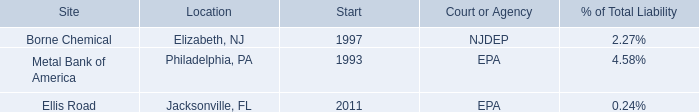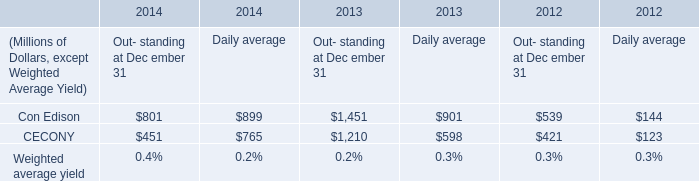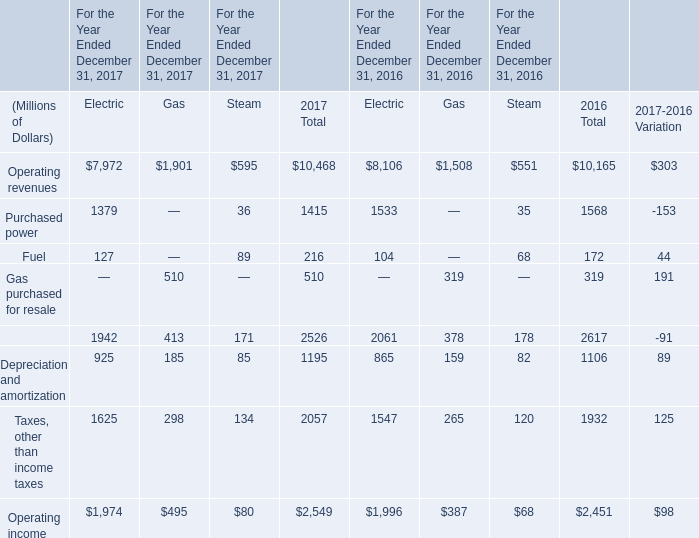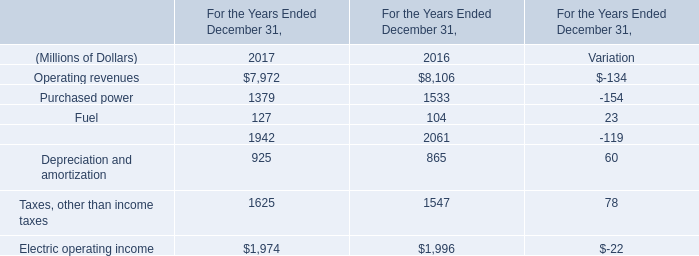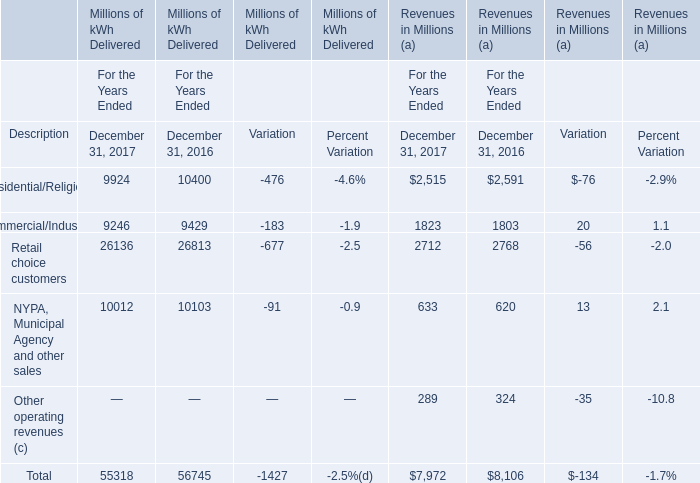If Depreciation and amortization with the same increasing rate in 2016, what will it reach in 2017? (in million) 
Computations: (925 * (1 + ((925 - 865) / 865)))
Answer: 989.16185. 